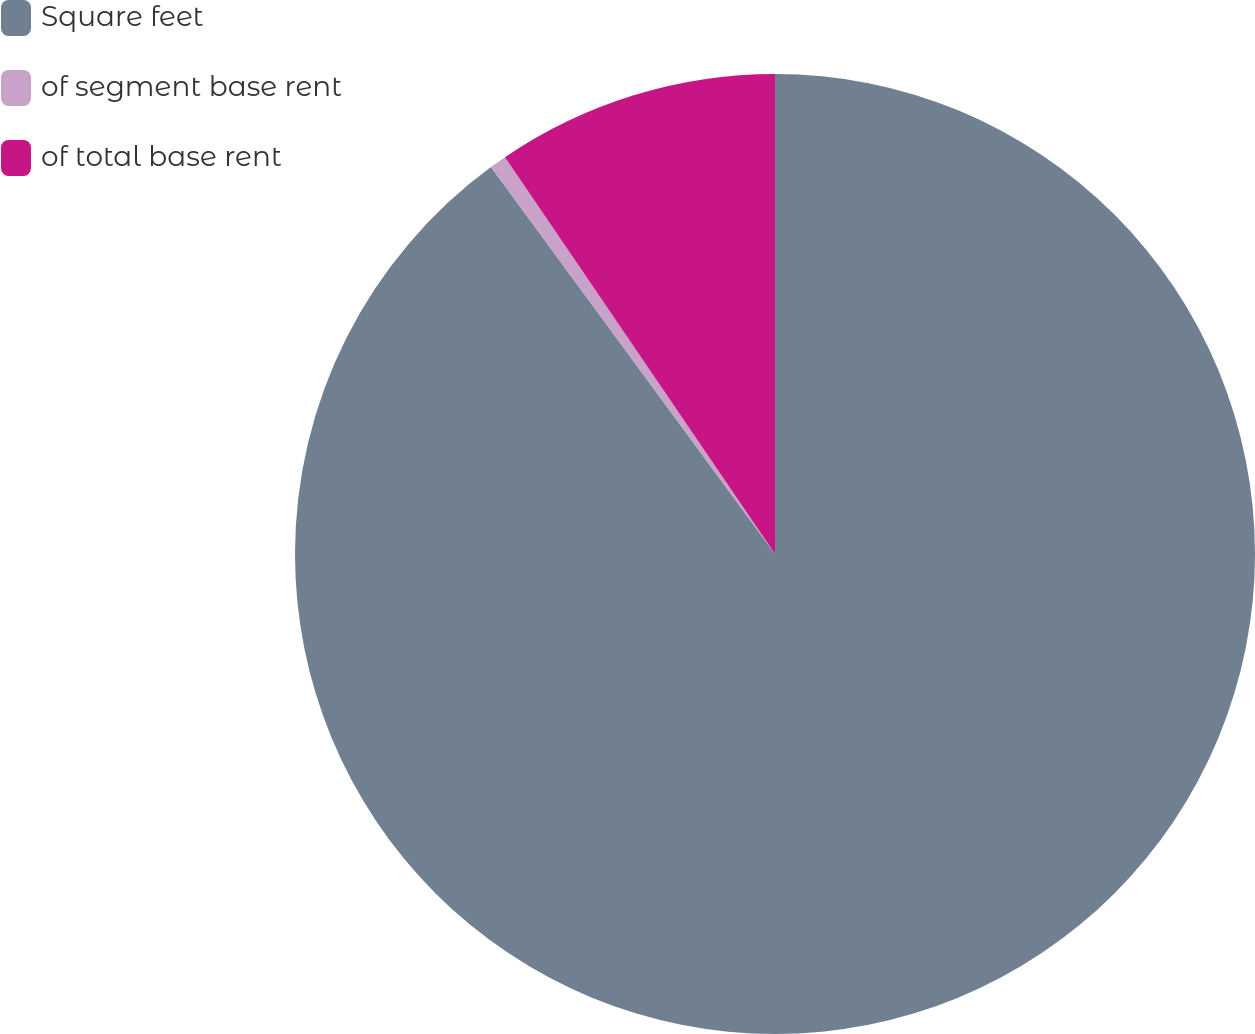<chart> <loc_0><loc_0><loc_500><loc_500><pie_chart><fcel>Square feet<fcel>of segment base rent<fcel>of total base rent<nl><fcel>89.92%<fcel>0.57%<fcel>9.51%<nl></chart> 